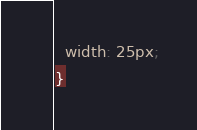<code> <loc_0><loc_0><loc_500><loc_500><_CSS_>  width: 25px;
}
</code> 